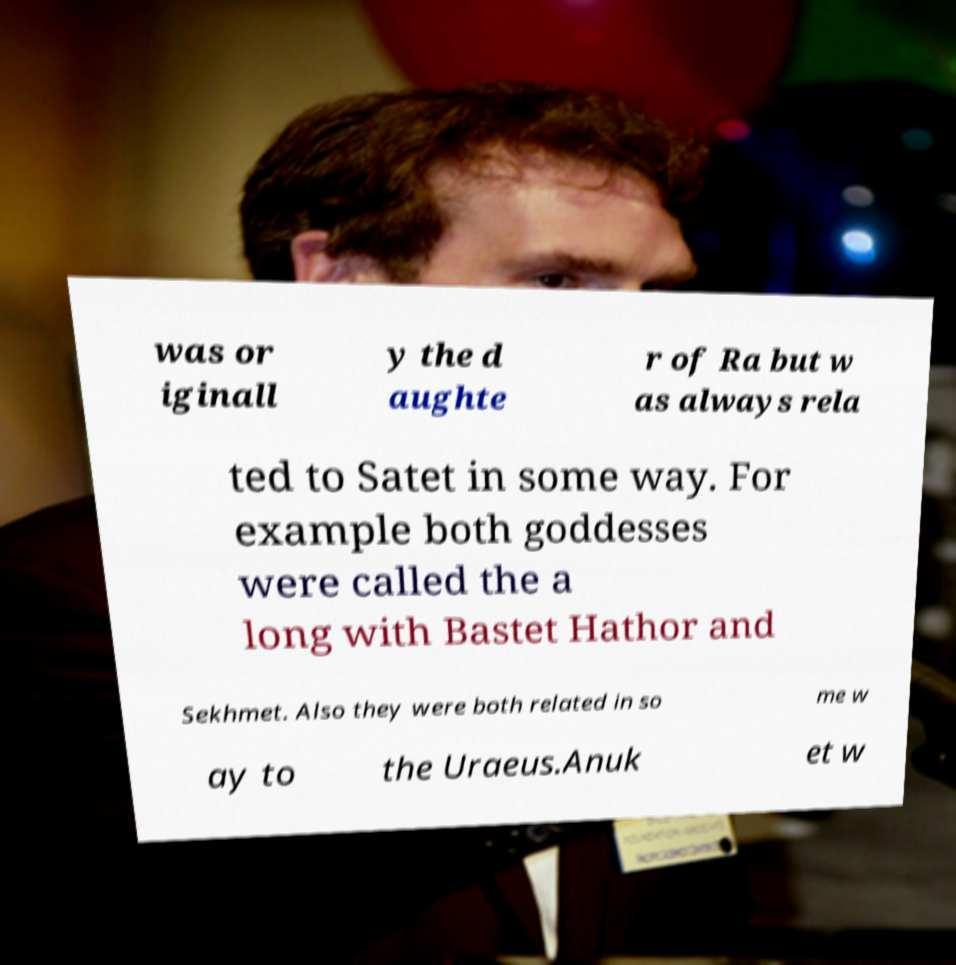Could you assist in decoding the text presented in this image and type it out clearly? was or iginall y the d aughte r of Ra but w as always rela ted to Satet in some way. For example both goddesses were called the a long with Bastet Hathor and Sekhmet. Also they were both related in so me w ay to the Uraeus.Anuk et w 